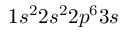Convert formula to latex. <formula><loc_0><loc_0><loc_500><loc_500>1 s ^ { 2 } 2 s ^ { 2 } 2 p ^ { 6 } 3 s</formula> 